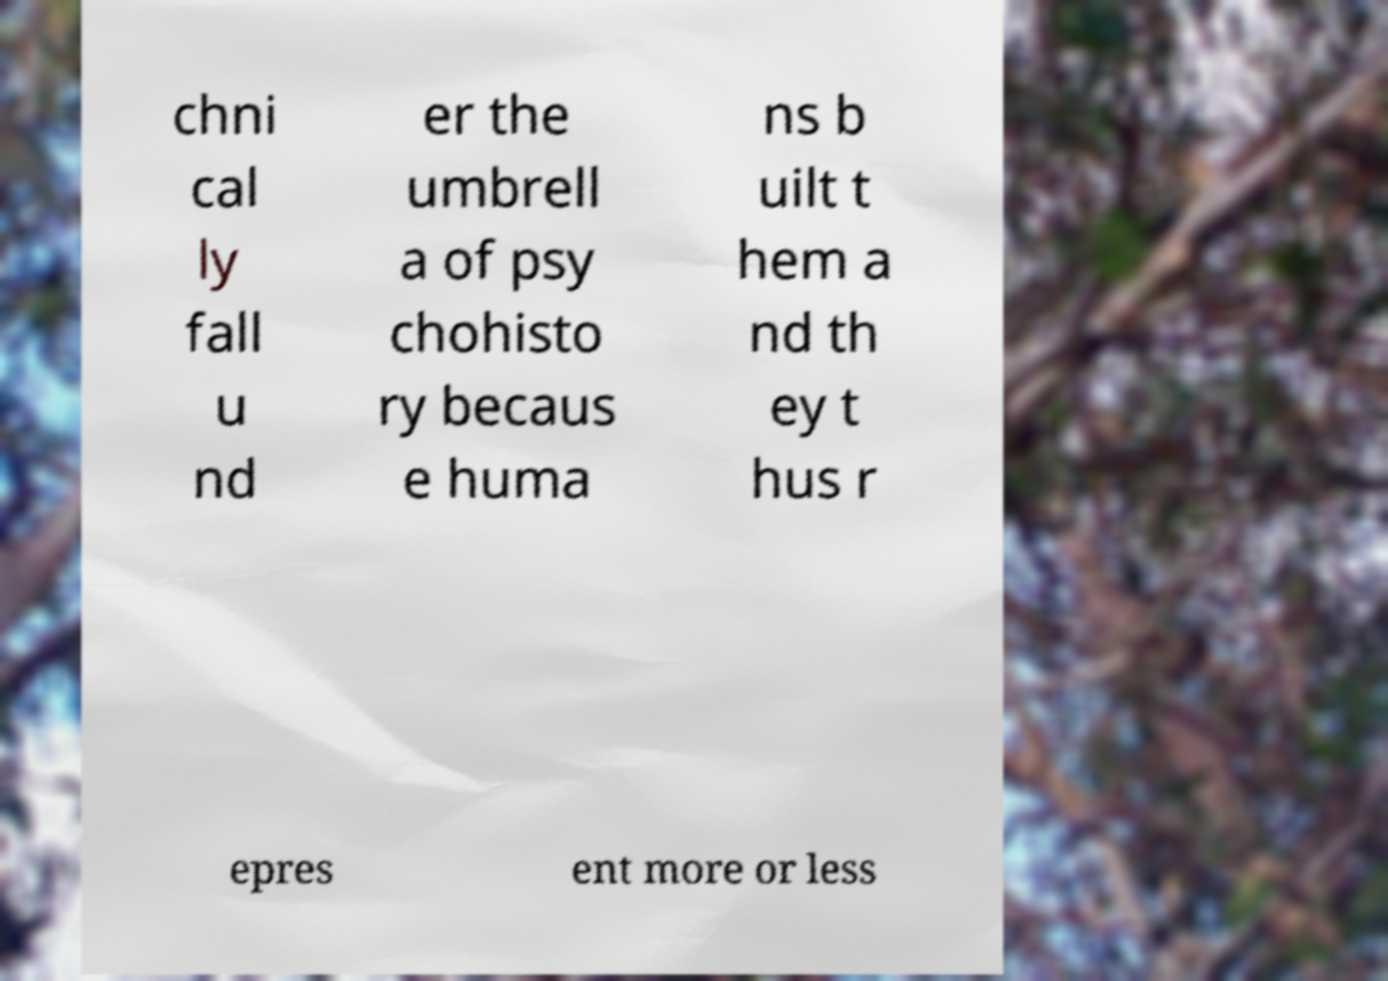Could you extract and type out the text from this image? chni cal ly fall u nd er the umbrell a of psy chohisto ry becaus e huma ns b uilt t hem a nd th ey t hus r epres ent more or less 